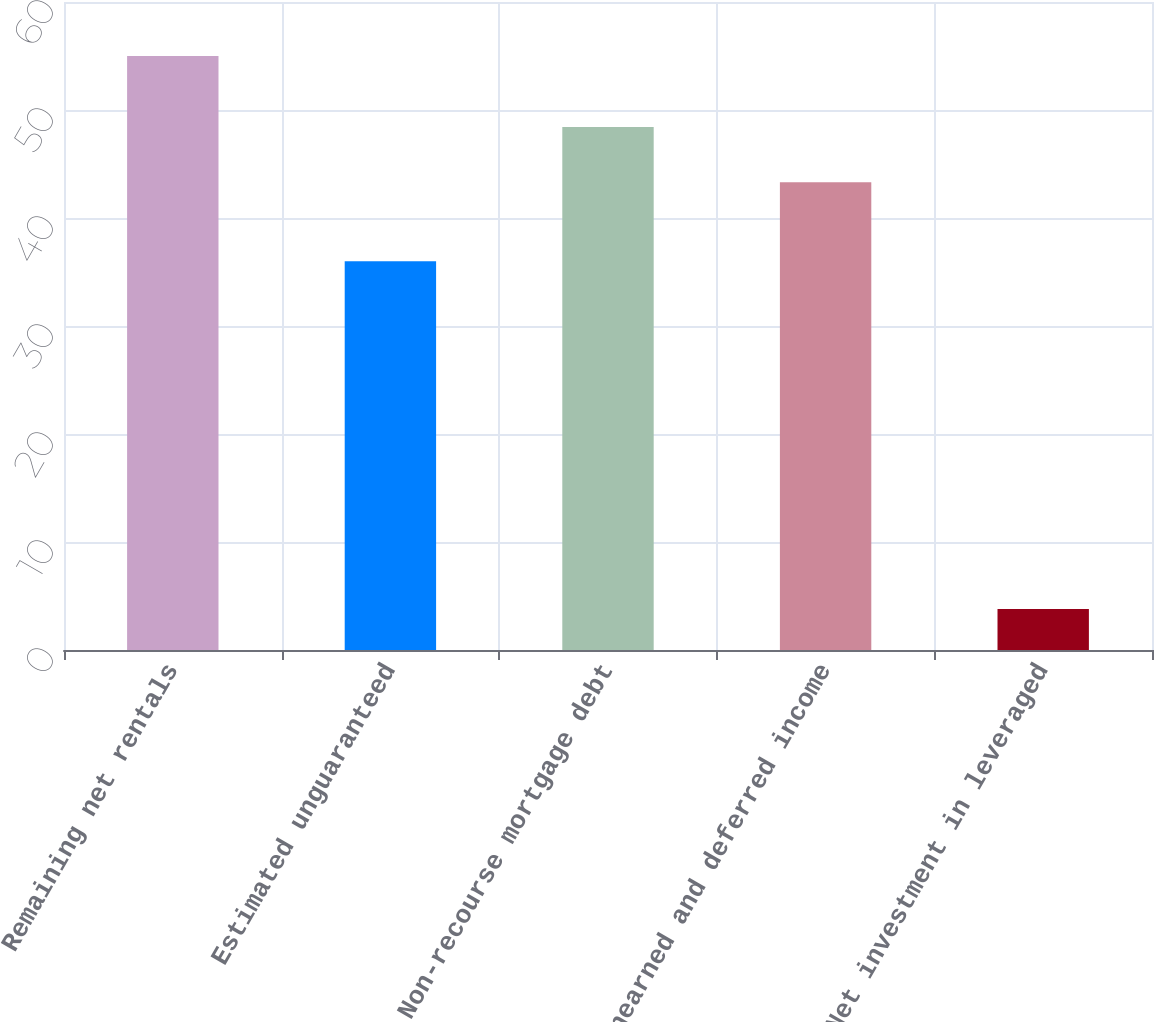Convert chart. <chart><loc_0><loc_0><loc_500><loc_500><bar_chart><fcel>Remaining net rentals<fcel>Estimated unguaranteed<fcel>Non-recourse mortgage debt<fcel>Unearned and deferred income<fcel>Net investment in leveraged<nl><fcel>55<fcel>36<fcel>48.42<fcel>43.3<fcel>3.8<nl></chart> 